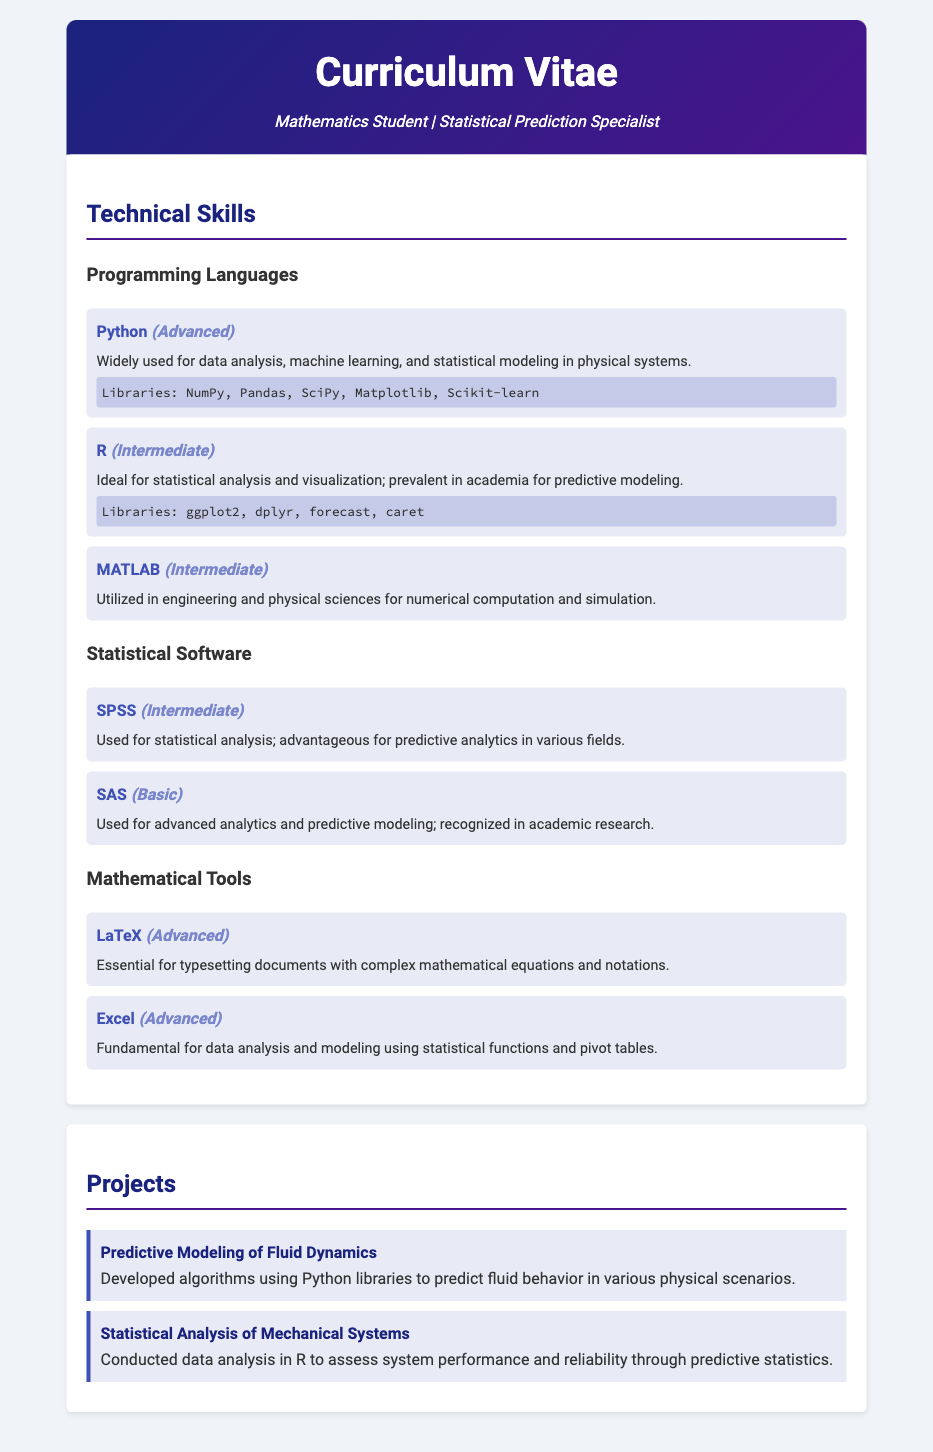What is the highest proficiency level for programming languages? The document lists Python as Advanced, while the others (R and MATLAB) are Intermediate, making Python the highest.
Answer: Advanced How many statistical software packages are listed? The document mentions two statistical software packages: SPSS and SAS.
Answer: Two Which programming language is described as ideal for statistical analysis? The document states that R is ideal for statistical analysis and visualization.
Answer: R What is the proficiency level of SAS? The document clearly states that SAS has a Basic proficiency level.
Answer: Basic What library is mentioned for Python skills? The document lists several libraries for Python, including NumPy and Pandas.
Answer: NumPy, Pandas, SciPy, Matplotlib, Scikit-learn Which tool is essential for typesetting documents with complex mathematical equations? The document identifies LaTeX as the essential tool for this purpose.
Answer: LaTeX In which section does the project related to fluid dynamics appear? The project about predictive modeling of fluid dynamics is listed under the Projects section.
Answer: Projects How many programming languages have an Intermediate proficiency level? The document explicitly mentions two languages at the Intermediate level, which are R and MATLAB.
Answer: Two What does the project on mechanical systems analyze? The project described assesses system performance and reliability through predictive statistics.
Answer: System performance and reliability 